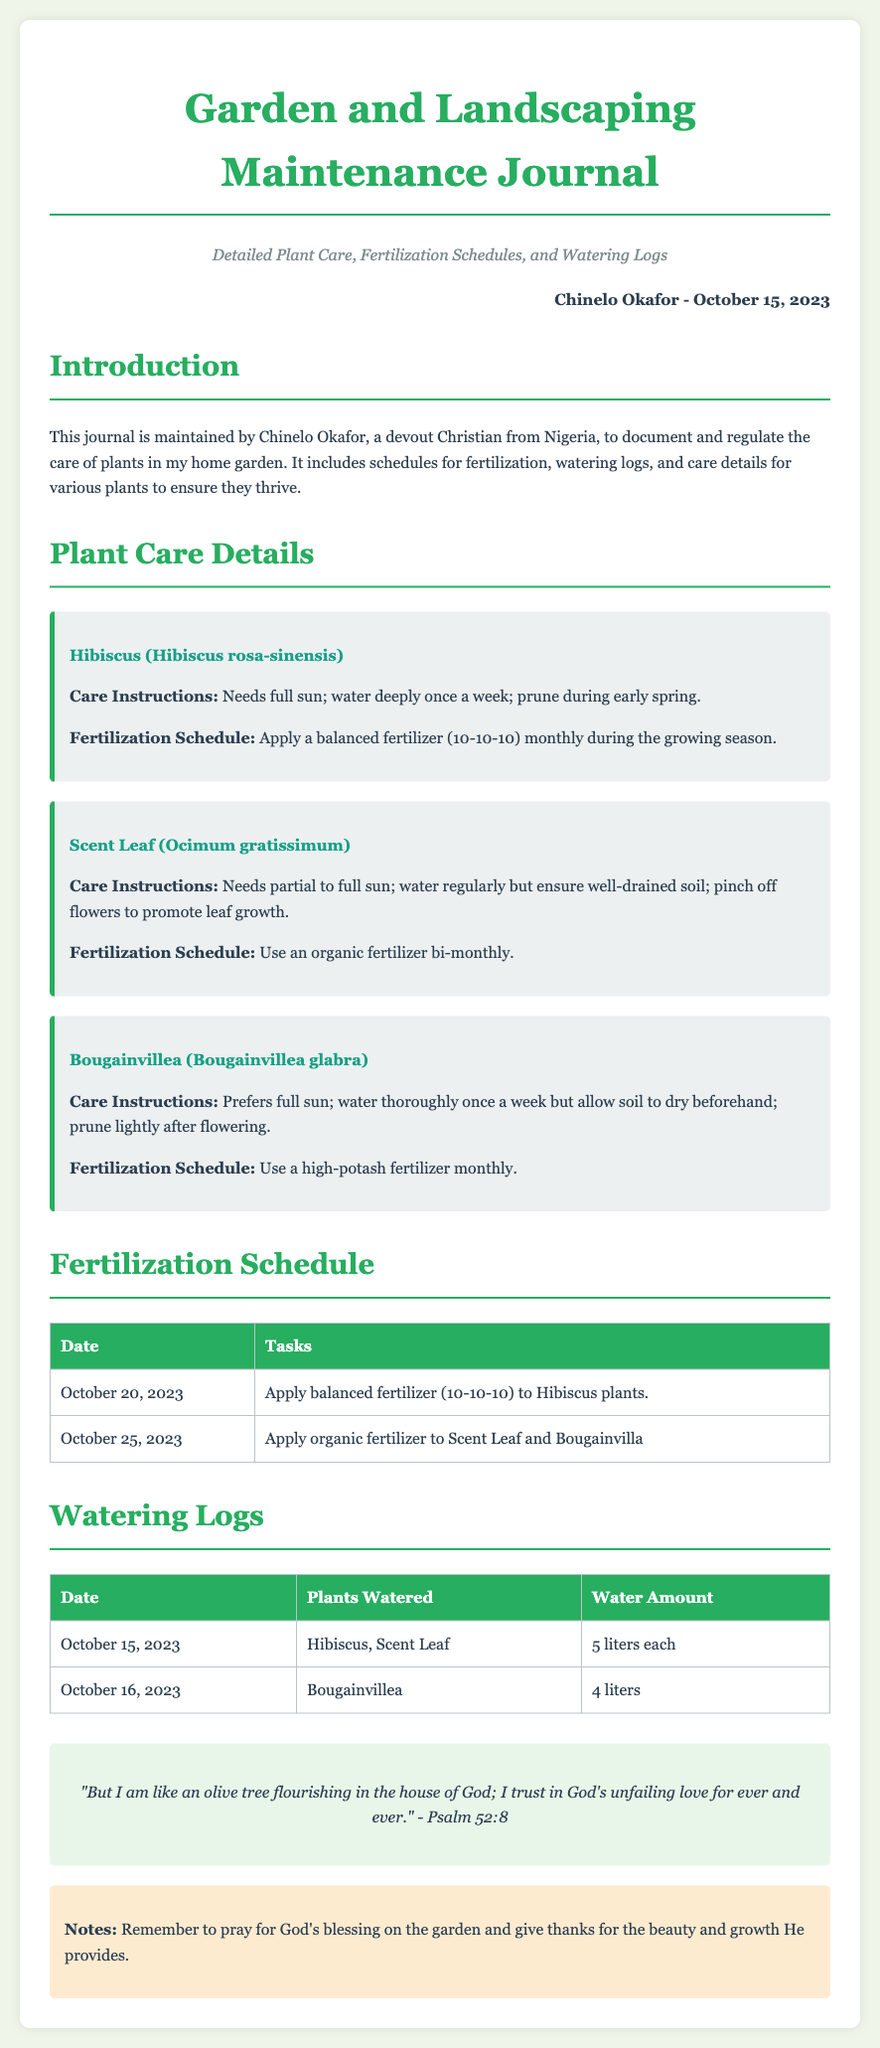What is the name of the maintained garden? The name of the garden is presented in the title of the journal as "Garden and Landscaping Maintenance Journal."
Answer: Garden and Landscaping Maintenance Journal Who is the journal maintained by? The owner's name is mentioned in the owner-date section at the top of the document.
Answer: Chinelo Okafor What is the watering schedule for Hibiscus? The document specifies that Hibiscus should be watered deeply once a week under care instructions.
Answer: Once a week When should you apply organic fertilizer to the Scent Leaf? The fertilization schedule indicates that organic fertilizer should be applied bi-monthly.
Answer: Bi-monthly How much water was given to the Bougainvillea on October 16, 2023? The watering log details the plants watered and the corresponding water amounts.
Answer: 4 liters What type of fertilizer should be used for Bougainvillea? The care instructions specify using a high-potash fertilizer monthly for Bougainvillea.
Answer: High-potash fertilizer What date is the next fertilization task scheduled? The next scheduled fertilization task is noted in the fertilization schedule table.
Answer: October 25, 2023 What was the water amount given to the Hibiscus on October 15, 2023? The watering log records the water amount given to Hibiscus on that date.
Answer: 5 liters 